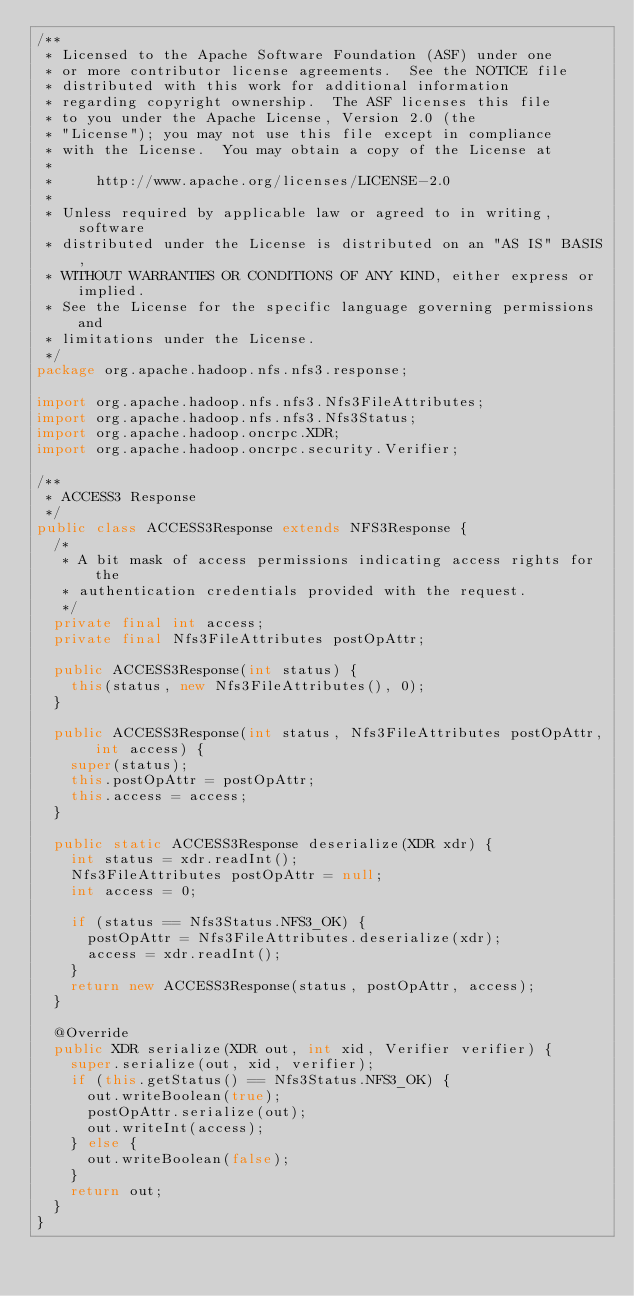<code> <loc_0><loc_0><loc_500><loc_500><_Java_>/**
 * Licensed to the Apache Software Foundation (ASF) under one
 * or more contributor license agreements.  See the NOTICE file
 * distributed with this work for additional information
 * regarding copyright ownership.  The ASF licenses this file
 * to you under the Apache License, Version 2.0 (the
 * "License"); you may not use this file except in compliance
 * with the License.  You may obtain a copy of the License at
 *
 *     http://www.apache.org/licenses/LICENSE-2.0
 *
 * Unless required by applicable law or agreed to in writing, software
 * distributed under the License is distributed on an "AS IS" BASIS,
 * WITHOUT WARRANTIES OR CONDITIONS OF ANY KIND, either express or implied.
 * See the License for the specific language governing permissions and
 * limitations under the License.
 */
package org.apache.hadoop.nfs.nfs3.response;

import org.apache.hadoop.nfs.nfs3.Nfs3FileAttributes;
import org.apache.hadoop.nfs.nfs3.Nfs3Status;
import org.apache.hadoop.oncrpc.XDR;
import org.apache.hadoop.oncrpc.security.Verifier;

/**
 * ACCESS3 Response 
 */
public class ACCESS3Response extends NFS3Response {
  /*
   * A bit mask of access permissions indicating access rights for the
   * authentication credentials provided with the request.
   */
  private final int access;
  private final Nfs3FileAttributes postOpAttr;
  
  public ACCESS3Response(int status) {
    this(status, new Nfs3FileAttributes(), 0);
  }
  
  public ACCESS3Response(int status, Nfs3FileAttributes postOpAttr, int access) {
    super(status);
    this.postOpAttr = postOpAttr;
    this.access = access;
  }

  public static ACCESS3Response deserialize(XDR xdr) {
    int status = xdr.readInt();
    Nfs3FileAttributes postOpAttr = null;
    int access = 0;

    if (status == Nfs3Status.NFS3_OK) {
      postOpAttr = Nfs3FileAttributes.deserialize(xdr);
      access = xdr.readInt();
    }
    return new ACCESS3Response(status, postOpAttr, access);
  }

  @Override
  public XDR serialize(XDR out, int xid, Verifier verifier) {
    super.serialize(out, xid, verifier);
    if (this.getStatus() == Nfs3Status.NFS3_OK) {
      out.writeBoolean(true);
      postOpAttr.serialize(out);
      out.writeInt(access);
    } else {
      out.writeBoolean(false);
    }
    return out;
  }
}</code> 